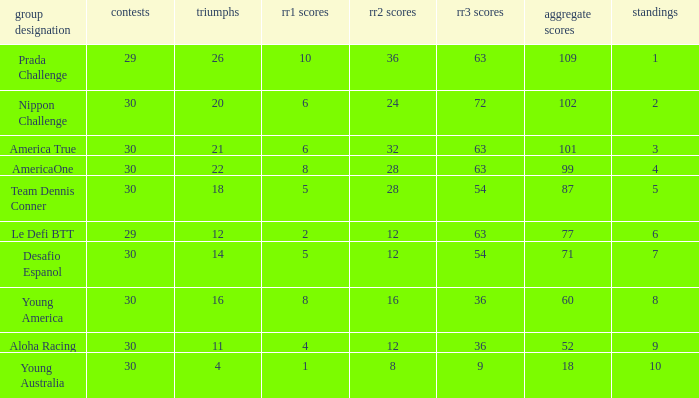Name the total number of rr2 pts for won being 11 1.0. 